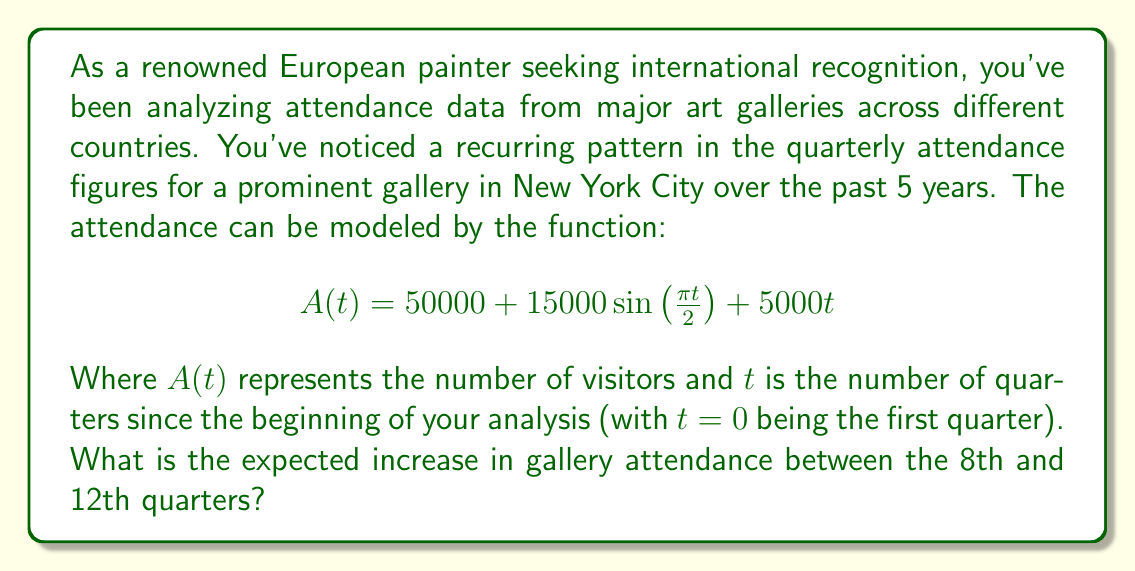Provide a solution to this math problem. To solve this problem, we need to follow these steps:

1) First, let's understand what each term in the function represents:
   - $50000$ is the base attendance
   - $15000\sin\left(\frac{\pi t}{2}\right)$ represents the seasonal fluctuation
   - $5000t$ represents the linear trend (increasing attendance over time)

2) We need to calculate the difference between $A(12)$ and $A(8)$:

   $$\Delta A = A(12) - A(8)$$

3) Let's calculate $A(12)$:
   
   $$A(12) = 50000 + 15000\sin\left(\frac{12\pi}{2}\right) + 5000(12)$$
   $$= 50000 + 15000\sin(6\pi) + 60000$$
   $$= 50000 + 0 + 60000 = 110000$$

4) Now, let's calculate $A(8)$:
   
   $$A(8) = 50000 + 15000\sin\left(\frac{8\pi}{2}\right) + 5000(8)$$
   $$= 50000 + 15000\sin(4\pi) + 40000$$
   $$= 50000 + 0 + 40000 = 90000$$

5) Finally, we can calculate the difference:

   $$\Delta A = A(12) - A(8) = 110000 - 90000 = 20000$$

The increase in attendance is 20,000 visitors.

Note: The sine term becomes zero at both t=8 and t=12 because these are full cycles (sin(4π) = sin(6π) = 0). The increase is entirely due to the linear trend term.
Answer: 20,000 visitors 